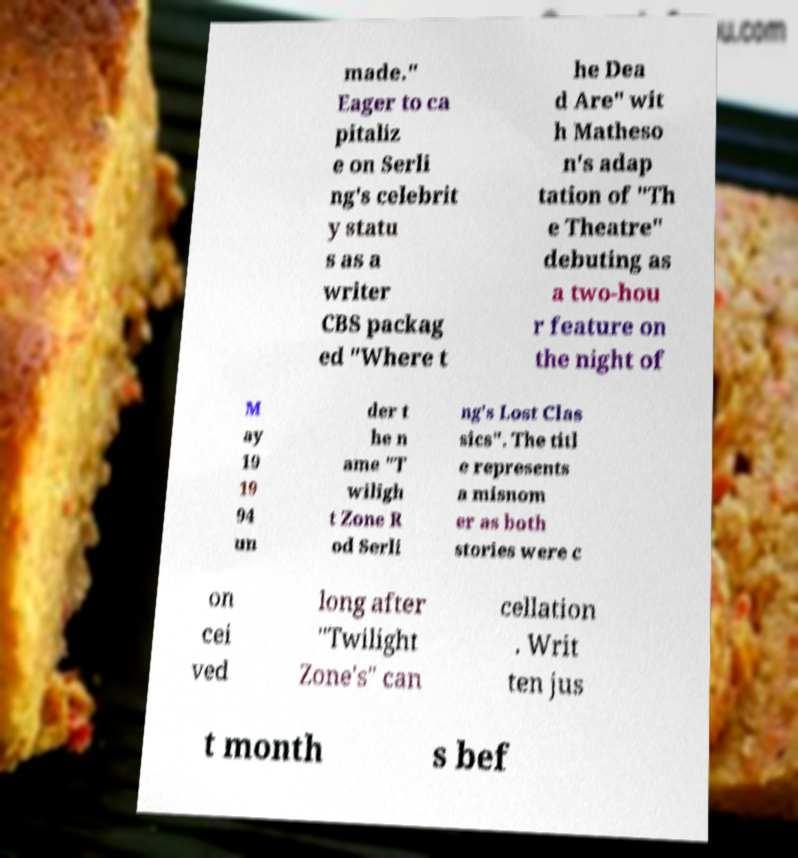There's text embedded in this image that I need extracted. Can you transcribe it verbatim? made." Eager to ca pitaliz e on Serli ng's celebrit y statu s as a writer CBS packag ed "Where t he Dea d Are" wit h Matheso n's adap tation of "Th e Theatre" debuting as a two-hou r feature on the night of M ay 19 19 94 un der t he n ame "T wiligh t Zone R od Serli ng's Lost Clas sics". The titl e represents a misnom er as both stories were c on cei ved long after "Twilight Zone's" can cellation . Writ ten jus t month s bef 